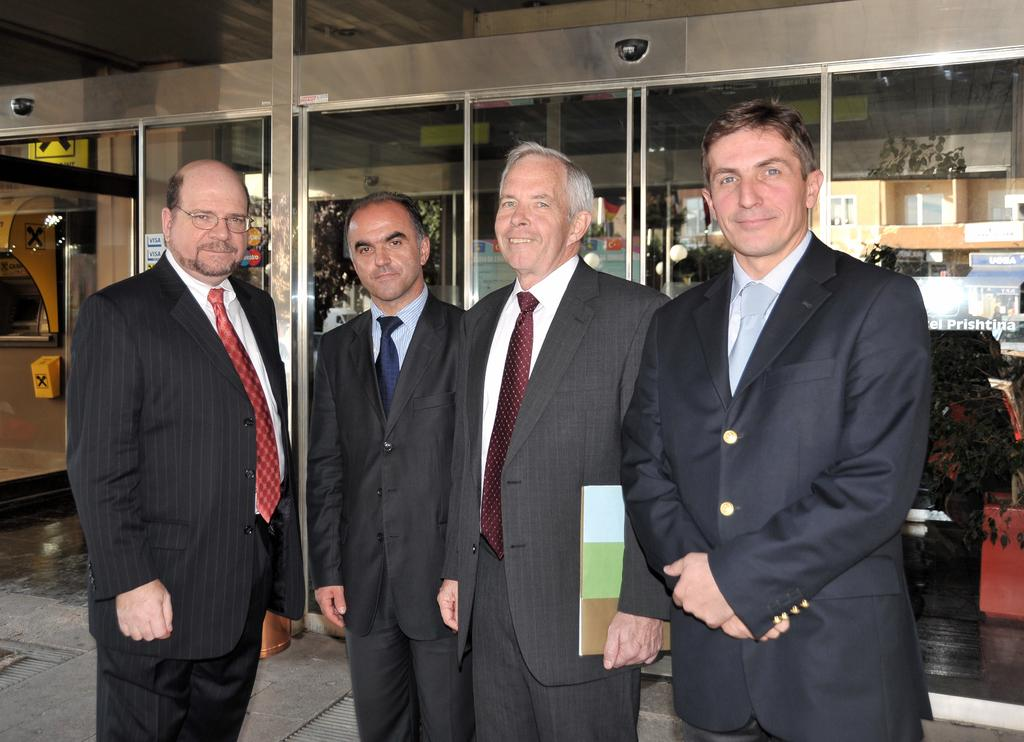How many people are in the image? There are four men in the image. What is the setting of the image? The men are standing on the land. What are the men wearing? The men are wearing coats and ties. What is the facial expression of the men? The men are smiling. What can be seen in the background of the image? There are glass doors in the background of the image. What type of pie is being served on the scarf in the image? There is no pie or scarf present in the image. How many apples are visible on the table in the image? There are no apples visible in the image. 